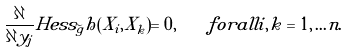<formula> <loc_0><loc_0><loc_500><loc_500>\frac { \partial } { \partial y _ { j } } H e s s _ { \widetilde { g } } h ( X _ { i } , X _ { k } ) = 0 , \quad f o r a l l i , k = 1 , \dots n .</formula> 